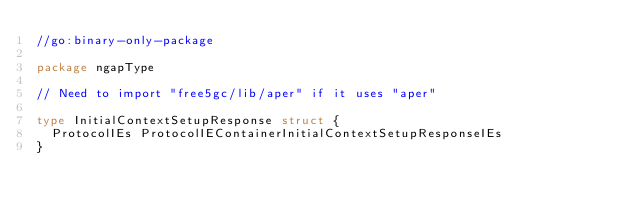Convert code to text. <code><loc_0><loc_0><loc_500><loc_500><_Go_>//go:binary-only-package

package ngapType

// Need to import "free5gc/lib/aper" if it uses "aper"

type InitialContextSetupResponse struct {
	ProtocolIEs ProtocolIEContainerInitialContextSetupResponseIEs
}
</code> 